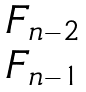Convert formula to latex. <formula><loc_0><loc_0><loc_500><loc_500>\begin{matrix} F _ { n - 2 } \\ F _ { n - 1 } \end{matrix}</formula> 